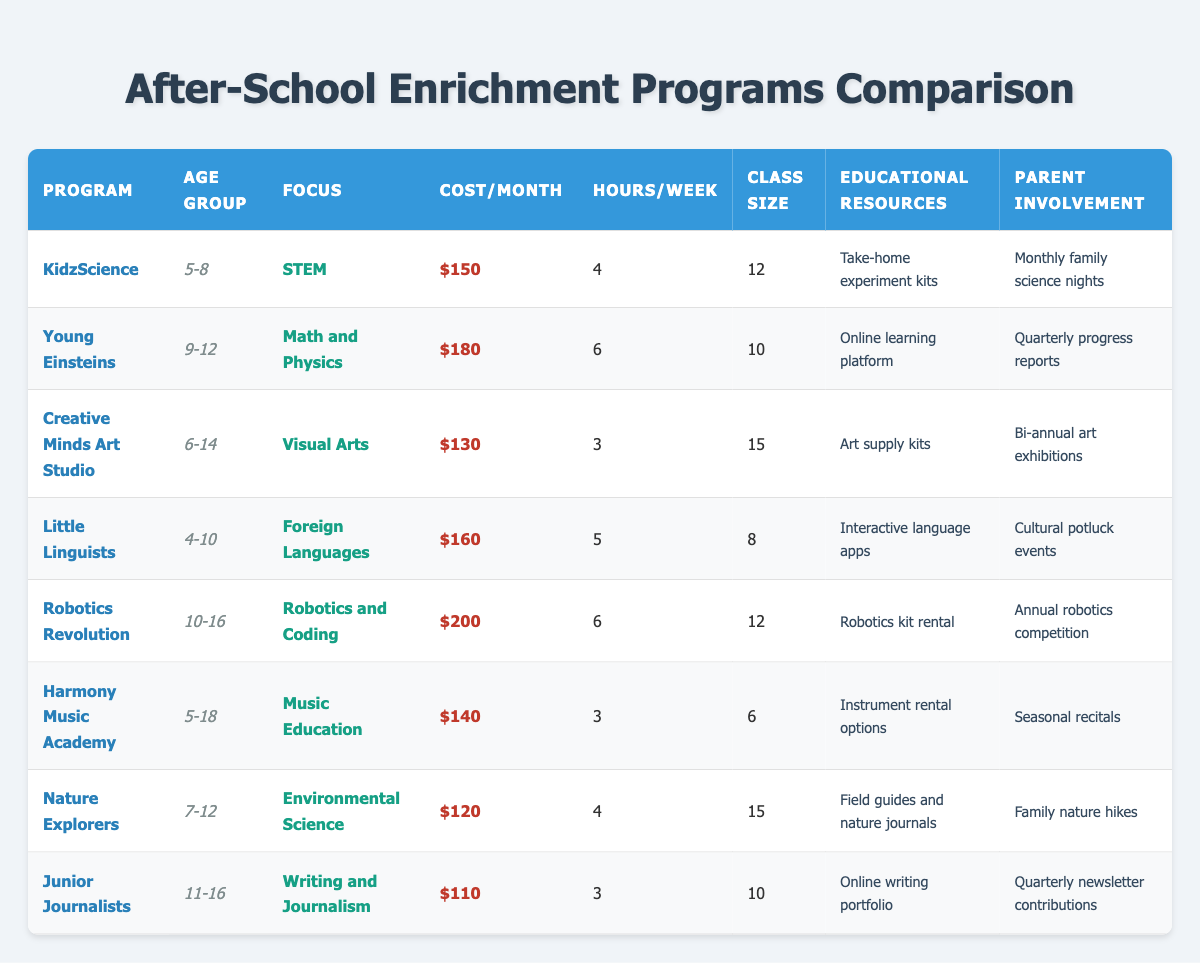What is the cost per month for the Robotics Revolution program? The cost per month is listed in the 'Cost/Month' column, corresponding to Robotics Revolution, which shows a value of $200.
Answer: $200 Which program has the highest class size? By comparing the 'Class Size' column, Creative Minds Art Studio has a class size of 15, which is greater than any other program listed.
Answer: 15 Is the Nature Explorers program suitable for 10-year-olds? The age group for Nature Explorers is 7-12, which includes 10-year-olds; therefore, it is suitable for them.
Answer: Yes What is the average cost per month for all programs? The costs are: KidzScience $150, Young Einsteins $180, Creative Minds Art Studio $130, Little Linguists $160, Robotics Revolution $200, Harmony Music Academy $140, Nature Explorers $120, Junior Journalists $110. Adding these gives a total of $1,090, and dividing by 8 programs gives an average cost of $136.25.
Answer: $136.25 How many programs focus on environmental science? Only one program, Nature Explorers, explicitly states environmental science as its focus in the 'Focus' column.
Answer: 1 Which program is the least expensive per month? By examining the 'Cost/Month' column, Junior Journalists is the least expensive at $110, which is lower than all other programs.
Answer: $110 What is the total duration of hours per week for programs catering to ages 5 to 8? For KidzScience, the duration is 4 hours, and for Harmony Music Academy, it's 3 hours. Adding these gives a total of 7 hours per week for the age group of 5 to 8.
Answer: 7 Do all programs offer take-home educational resources? Based on the 'Educational Resources' column, only KidzScience explicitly mentions take-home experiment kits; other programs provide different types of resources.
Answer: No Which program has the most extensive age group range, and what is that range? The Harmony Music Academy caters to the age group 5-18, which is the widest range listed among all programs.
Answer: 5-18 